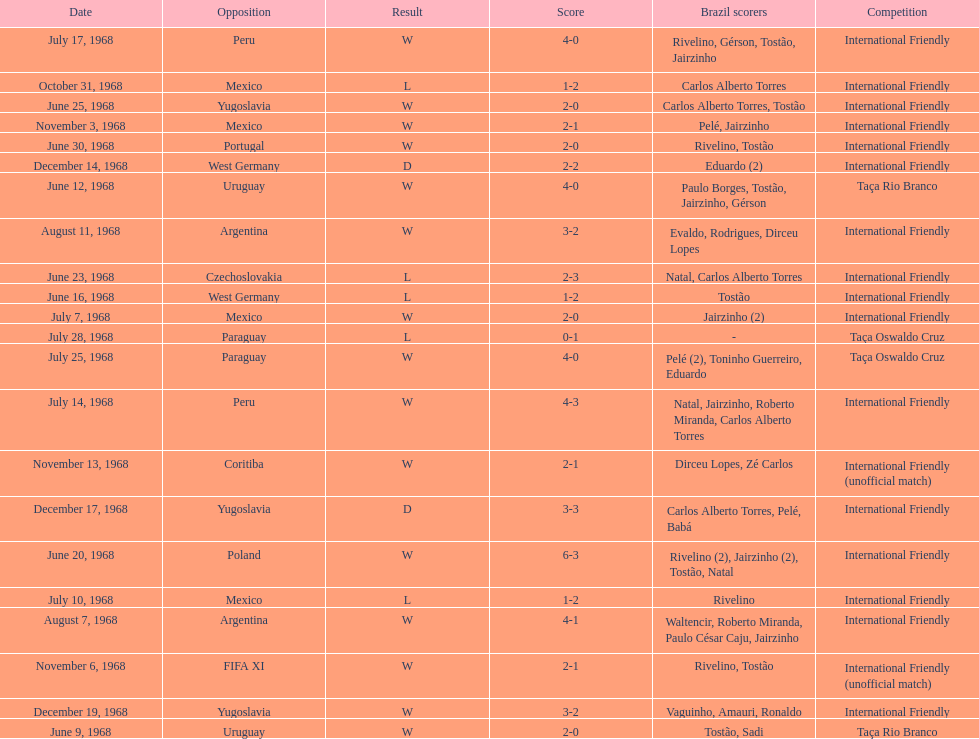How many ties are there in total? 2. 